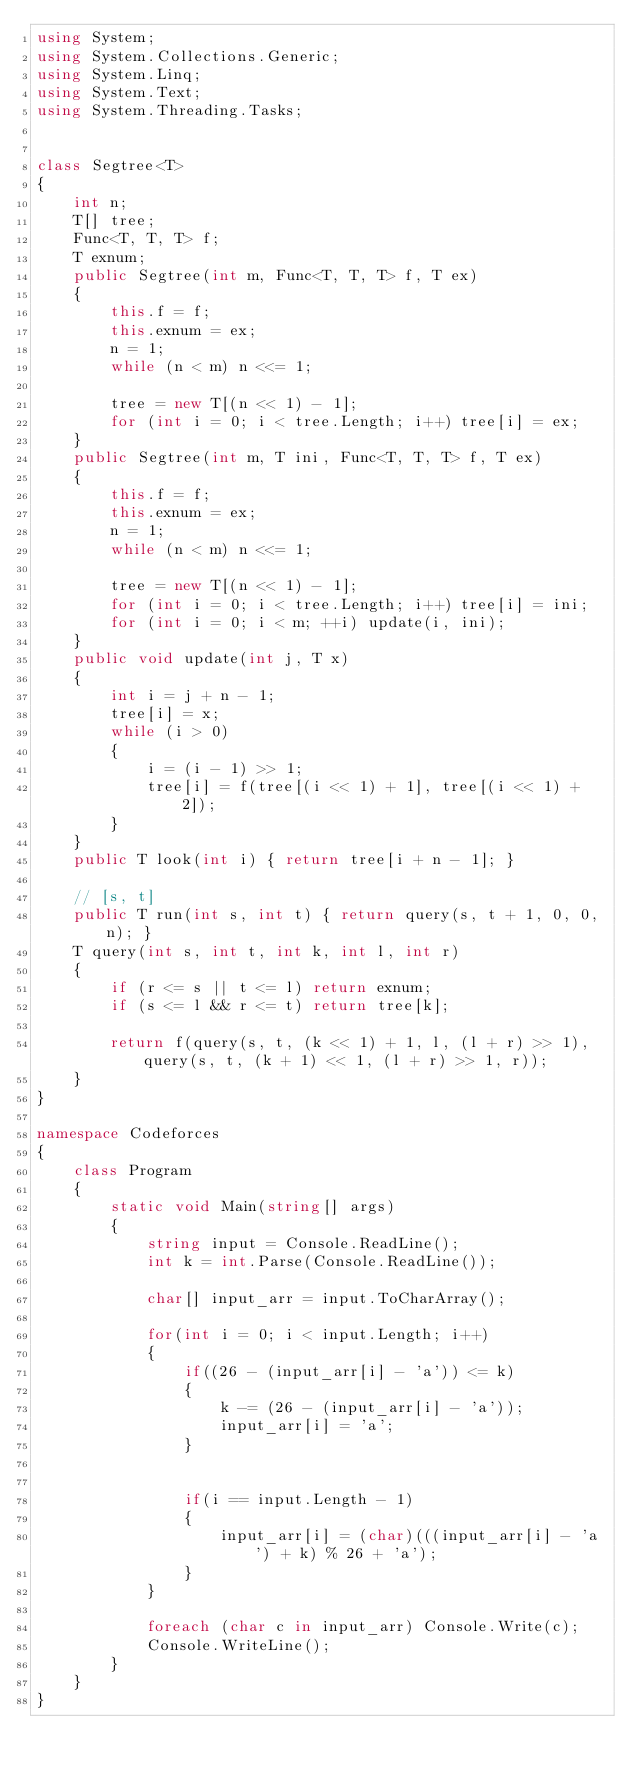<code> <loc_0><loc_0><loc_500><loc_500><_C#_>using System;
using System.Collections.Generic;
using System.Linq;
using System.Text;
using System.Threading.Tasks;


class Segtree<T>
{
    int n;
    T[] tree;
    Func<T, T, T> f;
    T exnum;
    public Segtree(int m, Func<T, T, T> f, T ex)
    {
        this.f = f;
        this.exnum = ex;
        n = 1;
        while (n < m) n <<= 1;

        tree = new T[(n << 1) - 1];
        for (int i = 0; i < tree.Length; i++) tree[i] = ex;
    }
    public Segtree(int m, T ini, Func<T, T, T> f, T ex)
    {
        this.f = f;
        this.exnum = ex;
        n = 1;
        while (n < m) n <<= 1;

        tree = new T[(n << 1) - 1];
        for (int i = 0; i < tree.Length; i++) tree[i] = ini;
        for (int i = 0; i < m; ++i) update(i, ini);
    }
    public void update(int j, T x)
    {
        int i = j + n - 1;
        tree[i] = x;
        while (i > 0)
        {
            i = (i - 1) >> 1;
            tree[i] = f(tree[(i << 1) + 1], tree[(i << 1) + 2]);
        }
    }
    public T look(int i) { return tree[i + n - 1]; }

    // [s, t]
    public T run(int s, int t) { return query(s, t + 1, 0, 0, n); }
    T query(int s, int t, int k, int l, int r)
    {
        if (r <= s || t <= l) return exnum;
        if (s <= l && r <= t) return tree[k];

        return f(query(s, t, (k << 1) + 1, l, (l + r) >> 1), query(s, t, (k + 1) << 1, (l + r) >> 1, r));
    }
}

namespace Codeforces
{
    class Program
    {
        static void Main(string[] args)
        {
            string input = Console.ReadLine();
            int k = int.Parse(Console.ReadLine());

            char[] input_arr = input.ToCharArray();

            for(int i = 0; i < input.Length; i++)
            {
                if((26 - (input_arr[i] - 'a')) <= k)
                {
                    k -= (26 - (input_arr[i] - 'a'));
                    input_arr[i] = 'a';
                }


                if(i == input.Length - 1)
                {
                    input_arr[i] = (char)(((input_arr[i] - 'a') + k) % 26 + 'a');
                }
            }

            foreach (char c in input_arr) Console.Write(c);
            Console.WriteLine();
        }
    }
}</code> 